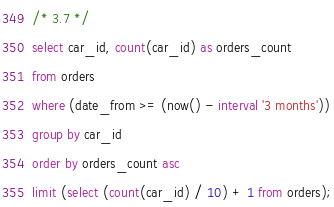Convert code to text. <code><loc_0><loc_0><loc_500><loc_500><_SQL_>/* 3.7 */
select car_id, count(car_id) as orders_count
from orders
where (date_from >= (now() - interval '3 months'))
group by car_id
order by orders_count asc
limit (select (count(car_id) / 10) + 1 from orders);</code> 